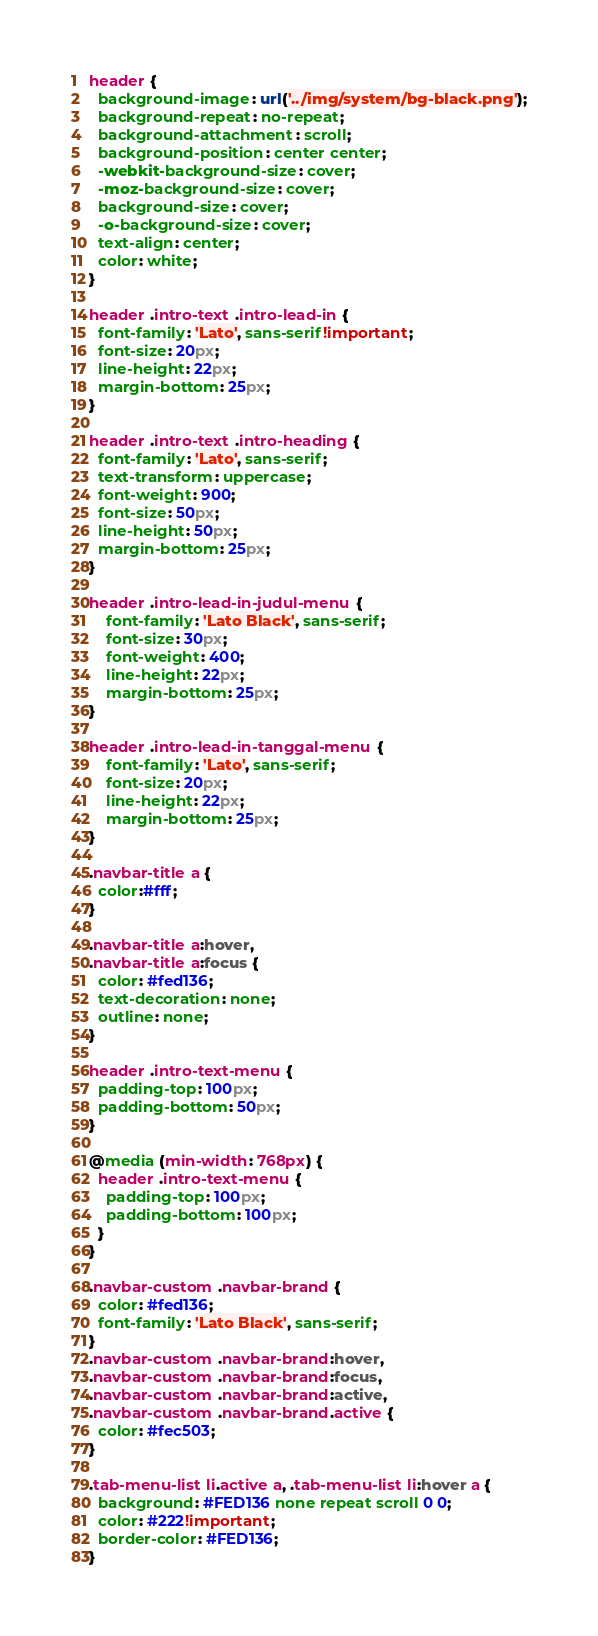Convert code to text. <code><loc_0><loc_0><loc_500><loc_500><_CSS_>
header {
  background-image: url('../img/system/bg-black.png');
  background-repeat: no-repeat;
  background-attachment: scroll;
  background-position: center center;
  -webkit-background-size: cover;
  -moz-background-size: cover;
  background-size: cover;
  -o-background-size: cover;
  text-align: center;
  color: white;
}

header .intro-text .intro-lead-in {
  font-family: 'Lato', sans-serif!important;
  font-size: 20px;
  line-height: 22px;
  margin-bottom: 25px;
}

header .intro-text .intro-heading {
  font-family: 'Lato', sans-serif;
  text-transform: uppercase;
  font-weight: 900;
  font-size: 50px;
  line-height: 50px;
  margin-bottom: 25px;
}

header .intro-lead-in-judul-menu {
	font-family: 'Lato Black', sans-serif;
  	font-size: 30px;
    font-weight: 400;
  	line-height: 22px;
  	margin-bottom: 25px;
}

header .intro-lead-in-tanggal-menu {
	font-family: 'Lato', sans-serif;
  	font-size: 20px;
  	line-height: 22px;
  	margin-bottom: 25px;
}

.navbar-title a {
  color:#fff;  
}

.navbar-title a:hover,
.navbar-title a:focus {
  color: #fed136;
  text-decoration: none;
  outline: none;
}

header .intro-text-menu {
  padding-top: 100px;
  padding-bottom: 50px;
}

@media (min-width: 768px) {
  header .intro-text-menu {
    padding-top: 100px;
    padding-bottom: 100px;
  }
}

.navbar-custom .navbar-brand {
  color: #fed136;
  font-family: 'Lato Black', sans-serif;
}
.navbar-custom .navbar-brand:hover,
.navbar-custom .navbar-brand:focus,
.navbar-custom .navbar-brand:active,
.navbar-custom .navbar-brand.active {
  color: #fec503;
}

.tab-menu-list li.active a, .tab-menu-list li:hover a {
  background: #FED136 none repeat scroll 0 0;
  color: #222!important;
  border-color: #FED136;
}

</code> 